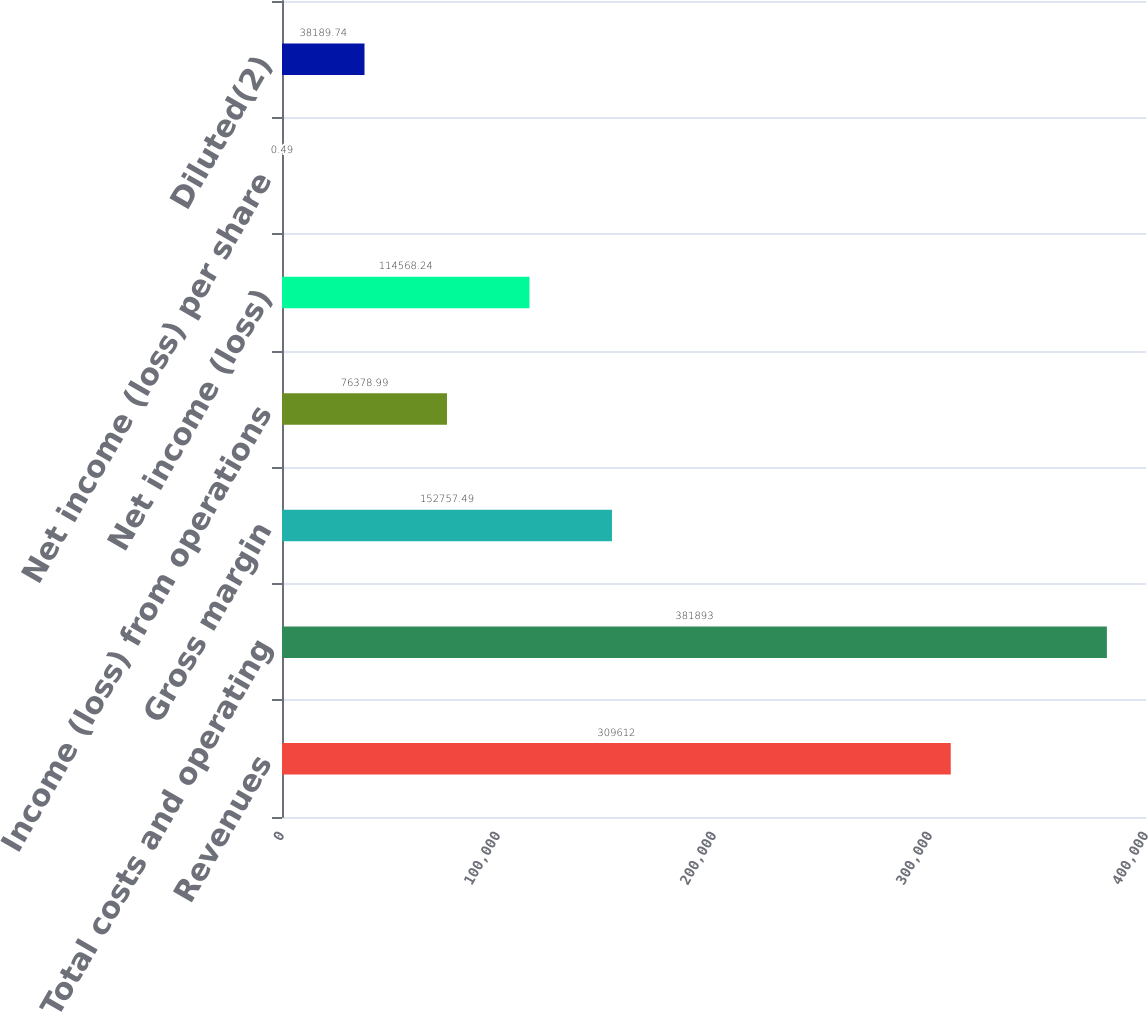Convert chart to OTSL. <chart><loc_0><loc_0><loc_500><loc_500><bar_chart><fcel>Revenues<fcel>Total costs and operating<fcel>Gross margin<fcel>Income (loss) from operations<fcel>Net income (loss)<fcel>Net income (loss) per share<fcel>Diluted(2)<nl><fcel>309612<fcel>381893<fcel>152757<fcel>76379<fcel>114568<fcel>0.49<fcel>38189.7<nl></chart> 